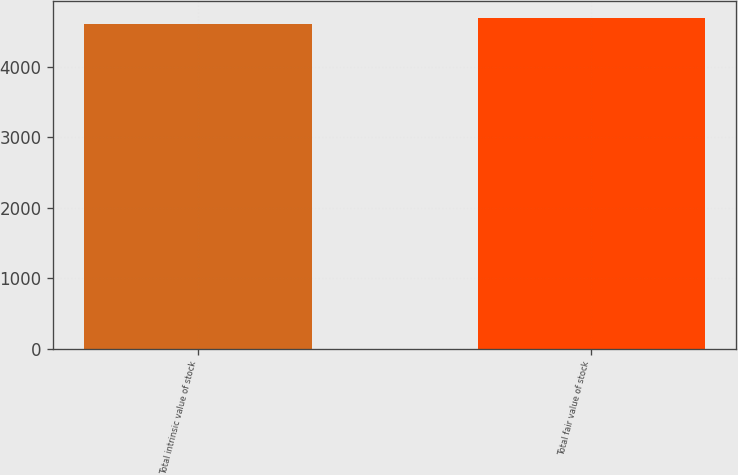<chart> <loc_0><loc_0><loc_500><loc_500><bar_chart><fcel>Total intrinsic value of stock<fcel>Total fair value of stock<nl><fcel>4604<fcel>4690<nl></chart> 